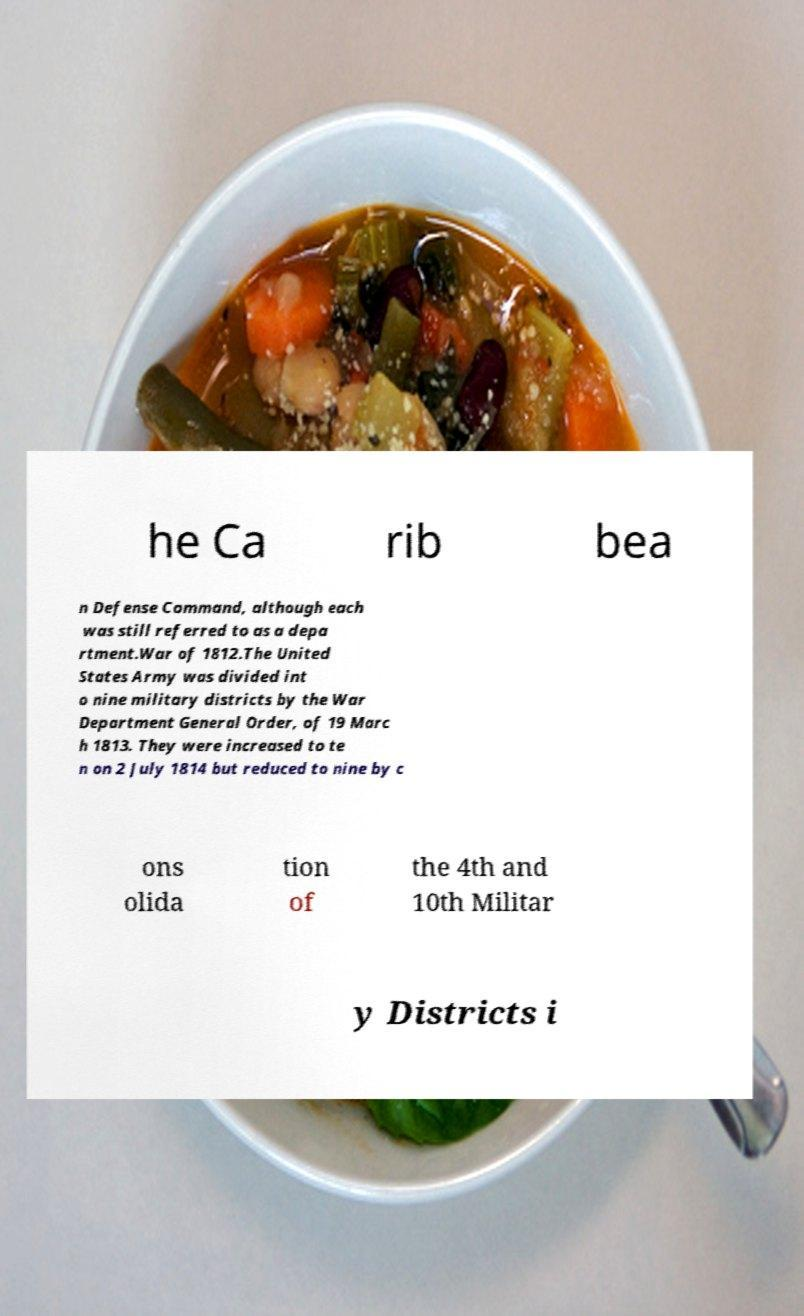I need the written content from this picture converted into text. Can you do that? he Ca rib bea n Defense Command, although each was still referred to as a depa rtment.War of 1812.The United States Army was divided int o nine military districts by the War Department General Order, of 19 Marc h 1813. They were increased to te n on 2 July 1814 but reduced to nine by c ons olida tion of the 4th and 10th Militar y Districts i 